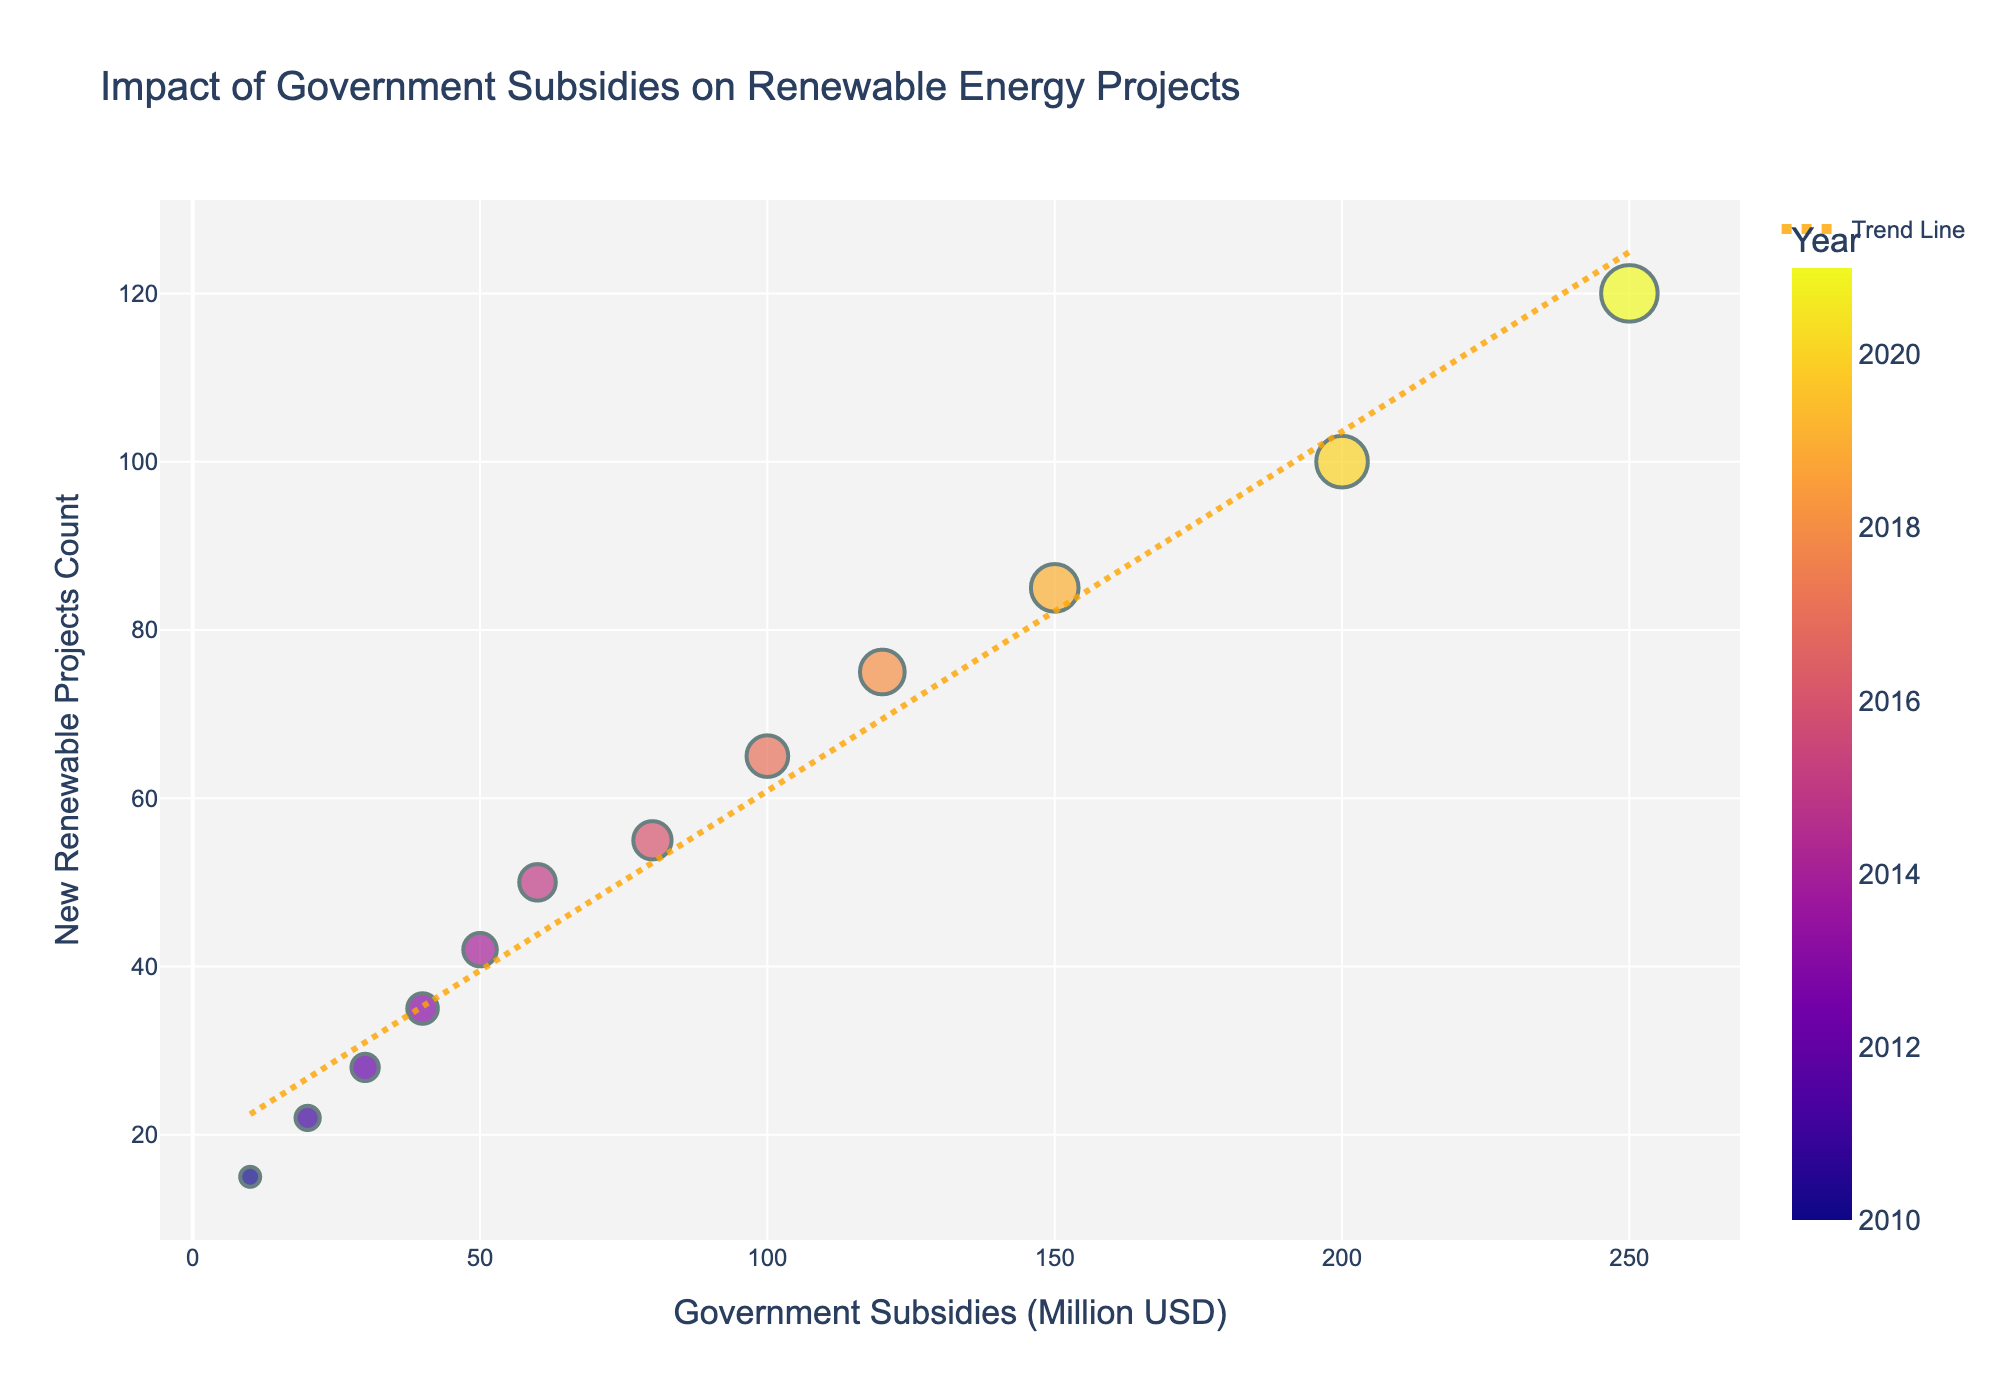What's the title of the scatter plot? The title of the scatter plot is displayed clearly at the top.
Answer: Impact of Government Subsidies on Renewable Energy Projects What are the labels on the x and y axes? The x-axis represents the subsidy amount given by the government in million USD and the y-axis represents the number of new renewable energy projects. They are clearly labeled.
Answer: Government Subsidies (Million USD) and New Renewable Projects Count How many data points are shown in the scatter plot? Each year from 2010 to 2021 corresponds to a data point, thus there are 12 data points visible in the scatter plot.
Answer: 12 What is the general trend indicated by the trend line? The trend line shows the overall pattern by fitting a linear line through the data points. From left to right, the trend line generally increases, indicating that more subsidies correlate with more new renewable projects.
Answer: Positive trend Which year had the maximum number of new renewable projects? By looking at the scatter plot, the highest point on the y-axis will indicate the year with the maximum number. The hover information can reveal this year.
Answer: 2021 What is the relationship between the subsidy amount and the number of new renewable projects? Based on the upward trend of the scatter plot and trend line, it indicates that as the subsidy amount increases, the number of new renewable projects also tends to increase.
Answer: Positive correlation Which year received a subsidy amount of 100 million USD? By identifying the data point located at the x-coordinate equivalent to 100 million USD, the hover information can reveal the year.
Answer: 2017 How many new renewable projects were there in 2015? By locating the data point labeled 2015, look at its position on the y-axis or use hover information to determine the number of new renewable projects.
Answer: 50 What is the difference in the number of new renewable projects between 2010 and 2021? Subtract the number of projects in 2010 from the number in 2021, based on their y-axis values or hover information. 120 (2021) - 15 (2010) = 105.
Answer: 105 Is there any visible outlier in the scatter plot? Look for any data points that deviate significantly from the general trend indicated by the scatter plot and trend line. No data points appear to be significant outliers in this plot.
Answer: No 